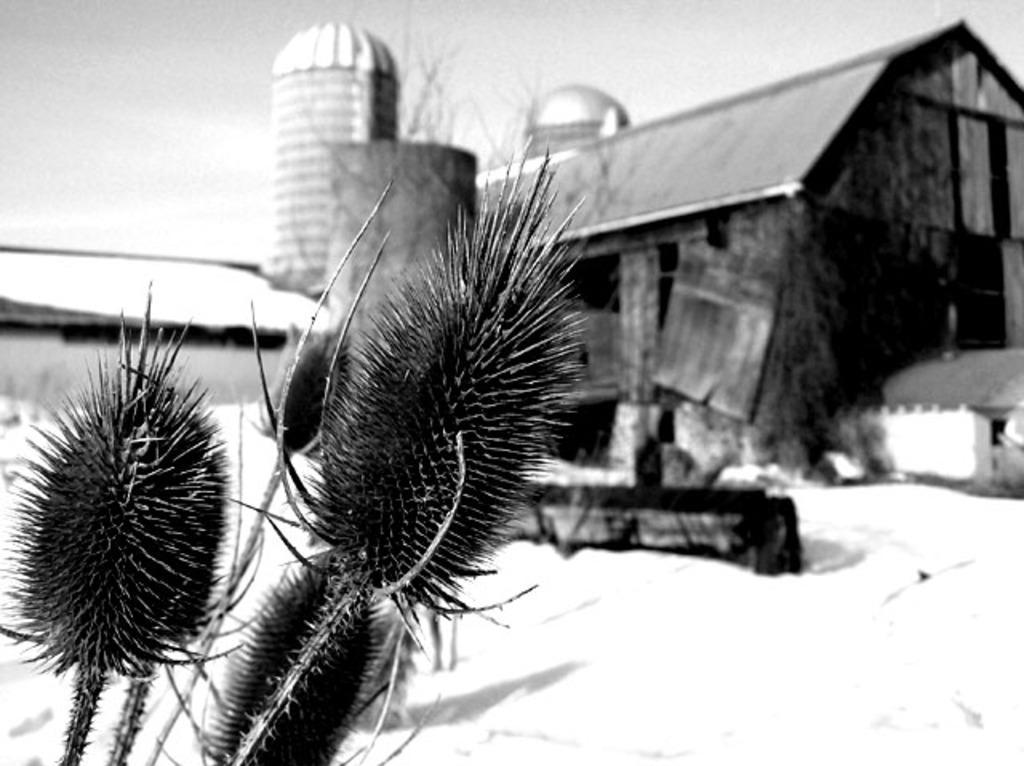Can you describe this image briefly? This is a black and white image. In this image we can see plants, snow, house, tree and sky. 